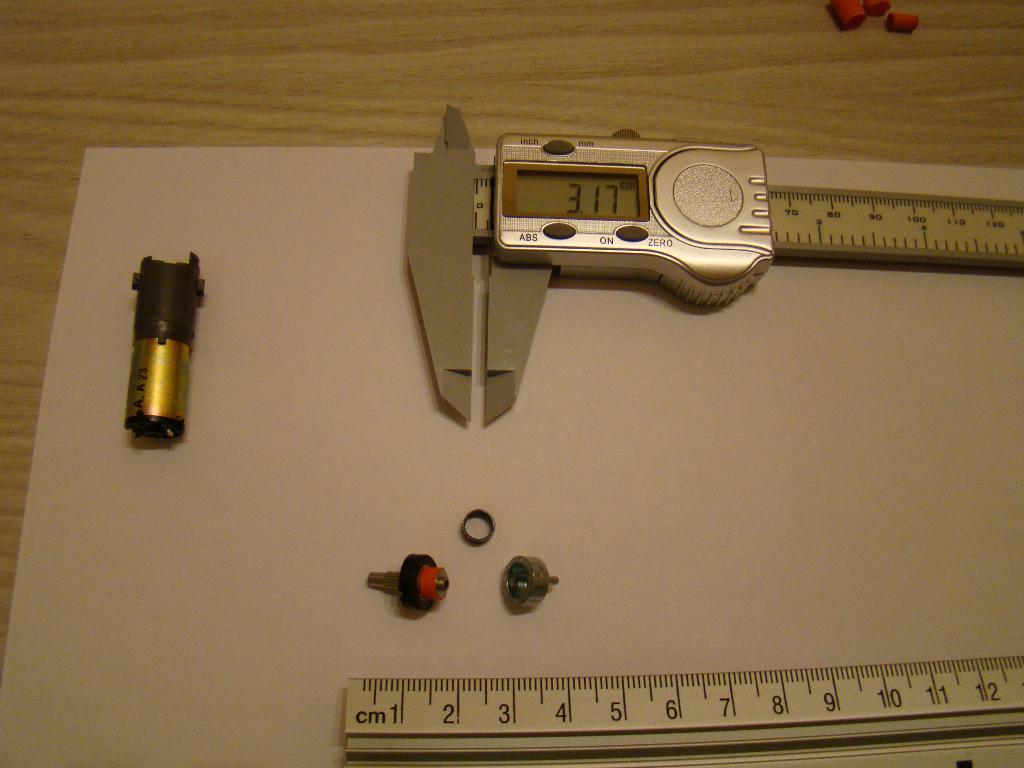Provide a one-sentence caption for the provided image. A micrometer measures a part at 3.17 millimeters. 